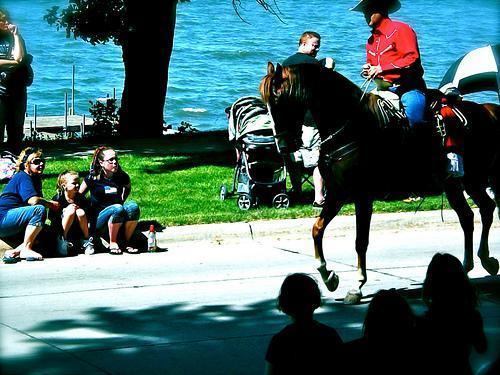How many horses in the photo?
Give a very brief answer. 1. How many people in the photo?
Give a very brief answer. 9. 